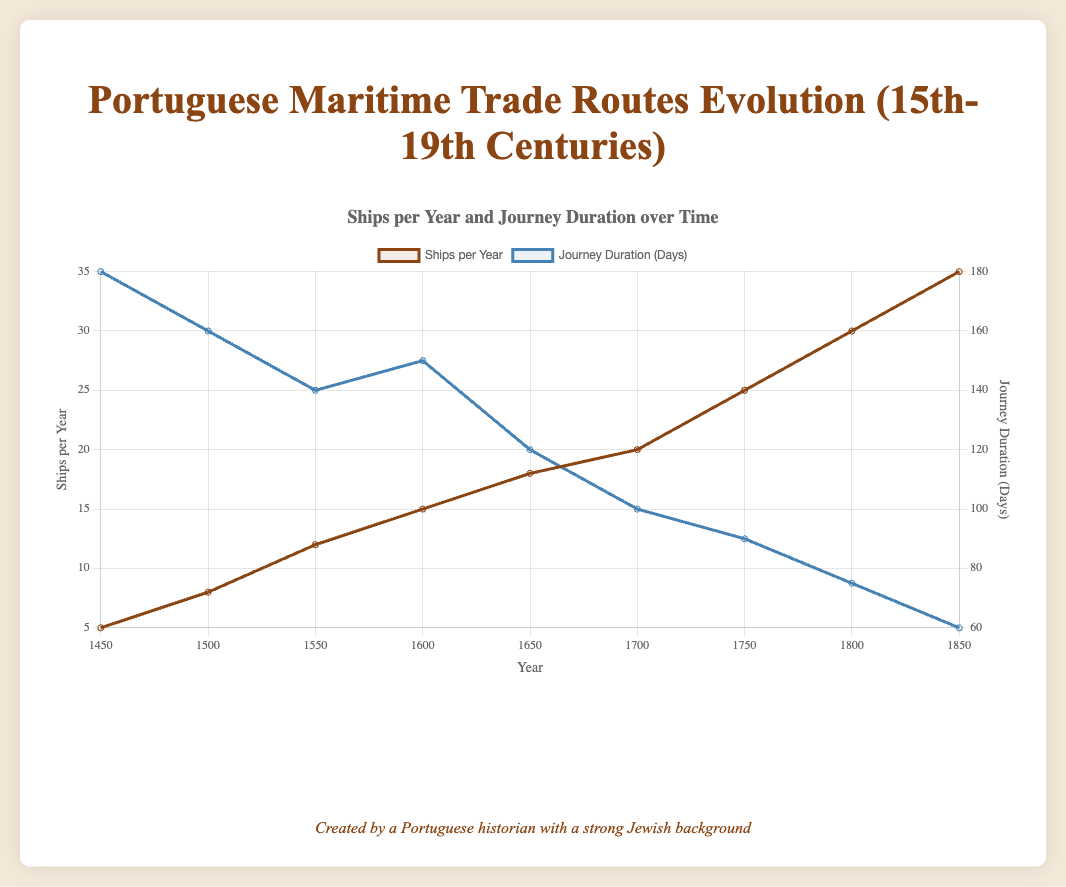What trend is observed in the number of ships per year between 1450 and 1850? The graph shows an increasing trend in the number of ships per year. For example, the number of ships increased from 5 in 1450 to 35 in 1850.
Answer: Increasing trend By how many days did the journey duration decrease from 1450 to 1850? The graph indicates that the journey duration decreased from 180 days in 1450 to 60 days in 1850. The difference is 180 - 60 = 120 days.
Answer: 120 days Which year had the highest number of ships per year according to the plot? The peak in the graph for the number of ships per year is at the year 1850, where the number is 35.
Answer: 1850 Compare the number of ships per year between 1500 and 1700. Which year had more ships? According to the graph, 1500 had 8 ships per year while 1700 had 20 ships per year. Therefore, 1700 had more ships.
Answer: 1700 What is the general relationship between ships per year and journey duration over time? As time progresses from 1450 to 1850, the number of ships per year increases while the journey duration decreases, indicating an inverse relationship between these two variables.
Answer: Inverse relationship What is the average number of ships per year from 1600 to 1800? The number of ships per year for 1600, 1650, 1700, 1750, and 1800 are 15, 18, 20, 25, and 30 respectively. The average is calculated as (15+18+20+25+30)/5 = 108/5 = 21.6.
Answer: 21.6 Which year had the shortest journey duration, and what was the duration? The lowest point on the journey duration curve is in the year 1850, where the duration is 60 days.
Answer: 1850 and 60 days How did the journey duration change from 1700 to 1750? According to the plot, the journey duration decreased from 100 days in 1700 to 90 days in 1750, a reduction of 10 days.
Answer: Decreased by 10 days Identify a period where the number of ships per year remained the same and state the years involved. The number of ships per year remains constant from 1500 to 1550, where it is 8 ships per year.
Answer: 1500 to 1550 